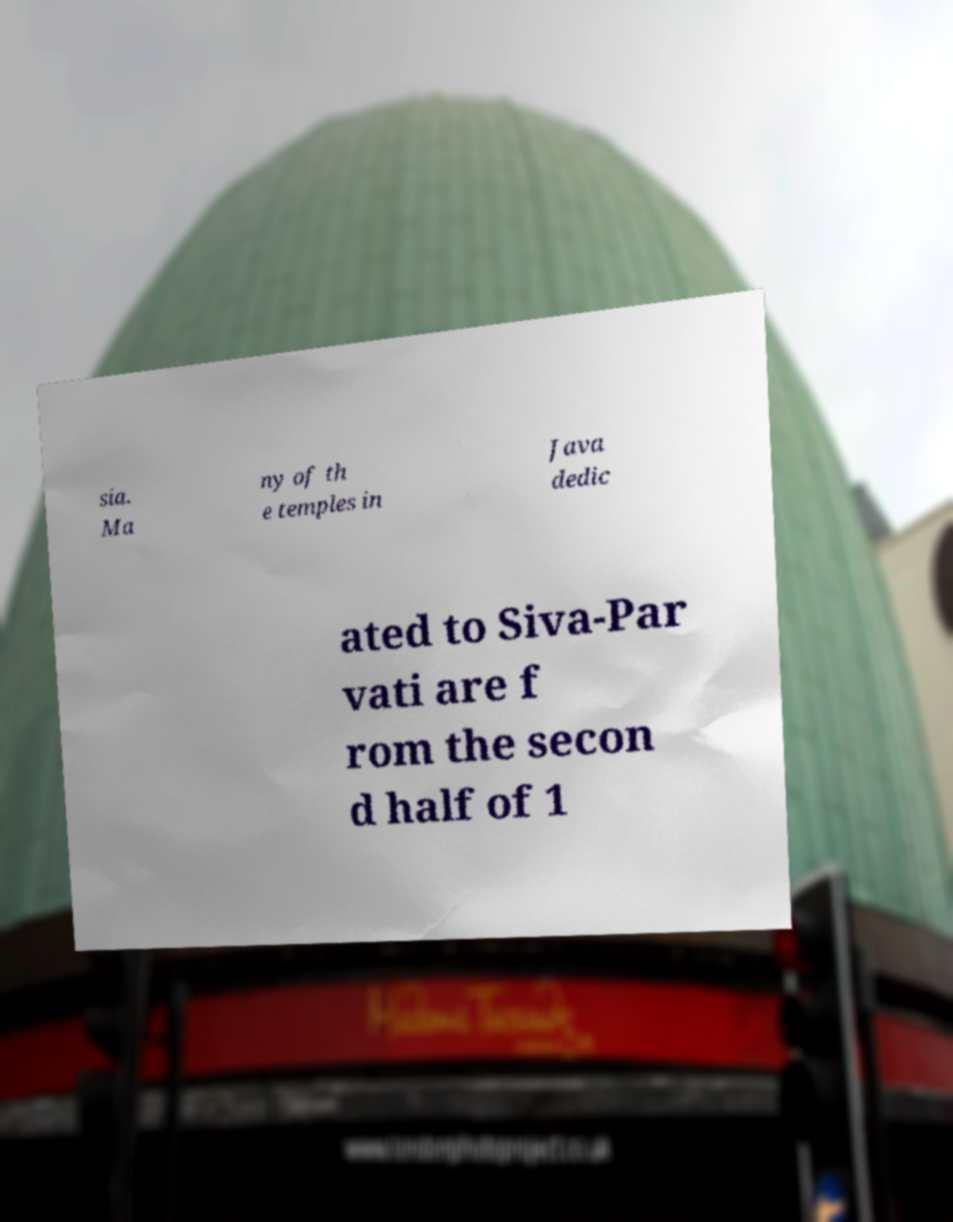Could you extract and type out the text from this image? sia. Ma ny of th e temples in Java dedic ated to Siva-Par vati are f rom the secon d half of 1 